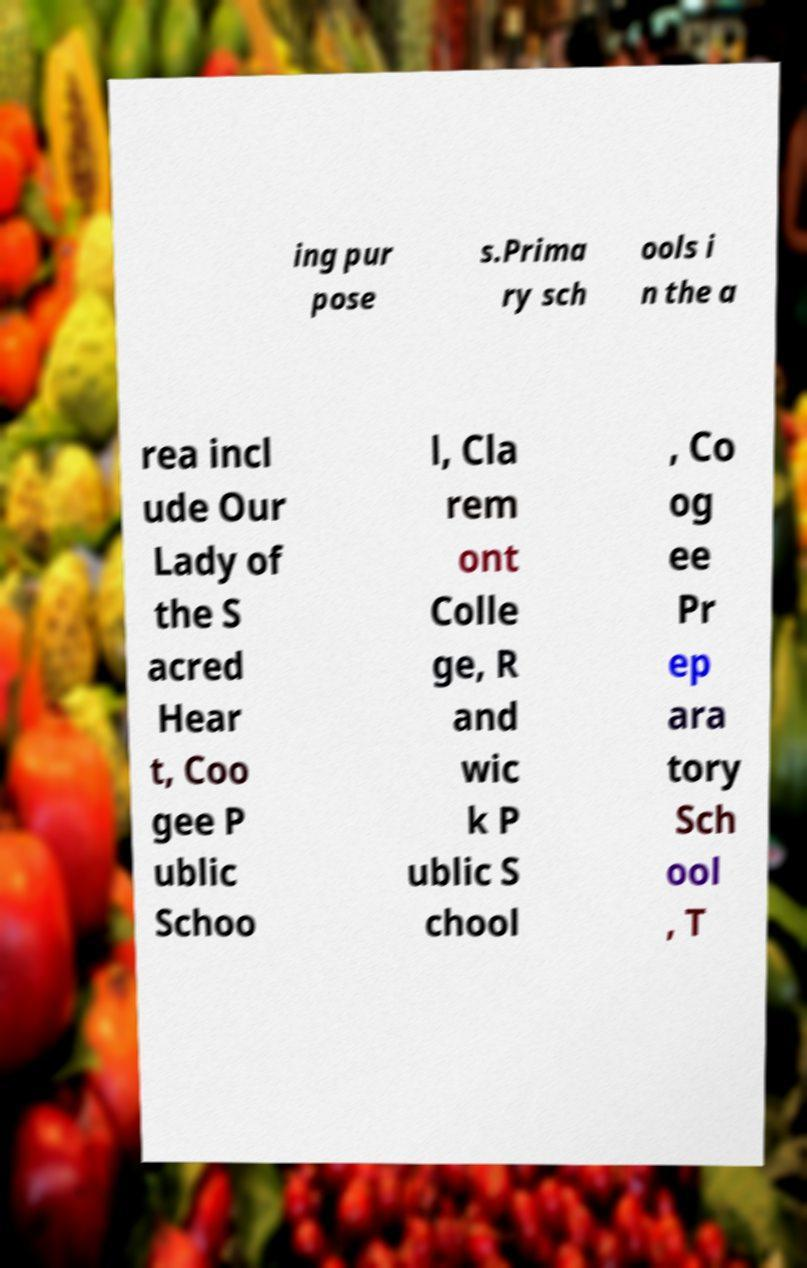Please read and relay the text visible in this image. What does it say? ing pur pose s.Prima ry sch ools i n the a rea incl ude Our Lady of the S acred Hear t, Coo gee P ublic Schoo l, Cla rem ont Colle ge, R and wic k P ublic S chool , Co og ee Pr ep ara tory Sch ool , T 